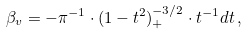<formula> <loc_0><loc_0><loc_500><loc_500>\beta _ { v } = - \pi ^ { - 1 } \cdot ( 1 - t ^ { 2 } ) _ { + } ^ { - 3 / 2 } \cdot t ^ { - 1 } d t \, ,</formula> 